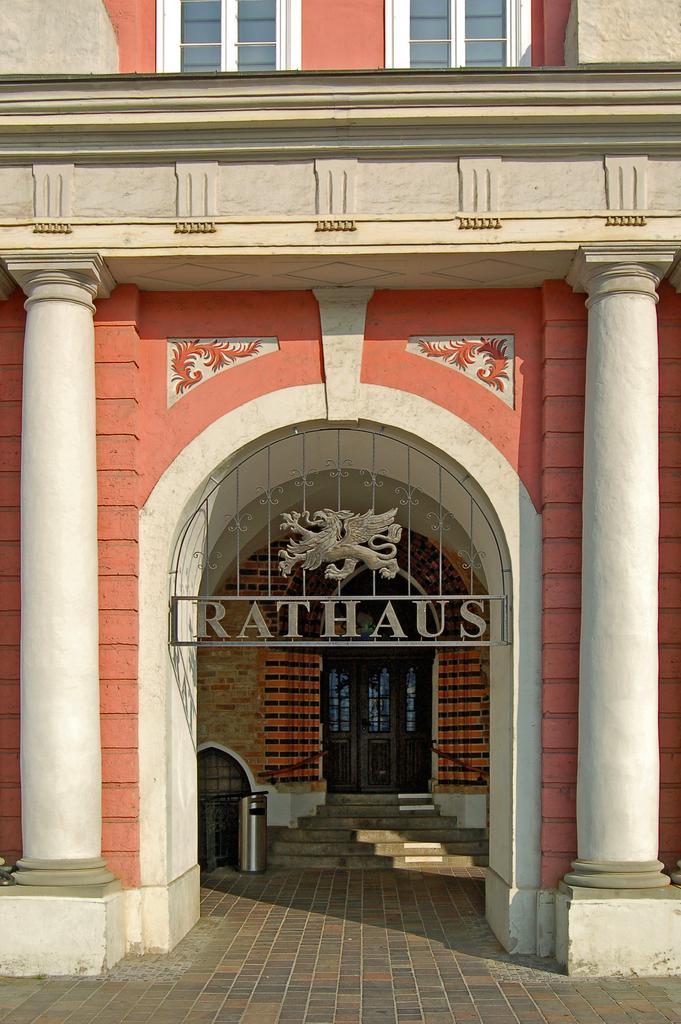Describe this image in one or two sentences. In this picture we can see an arch in the front, on the right side and left side there are pillars, in the background we can see a door, there is a dustbin here, we can see two windows at the top of the picture. 